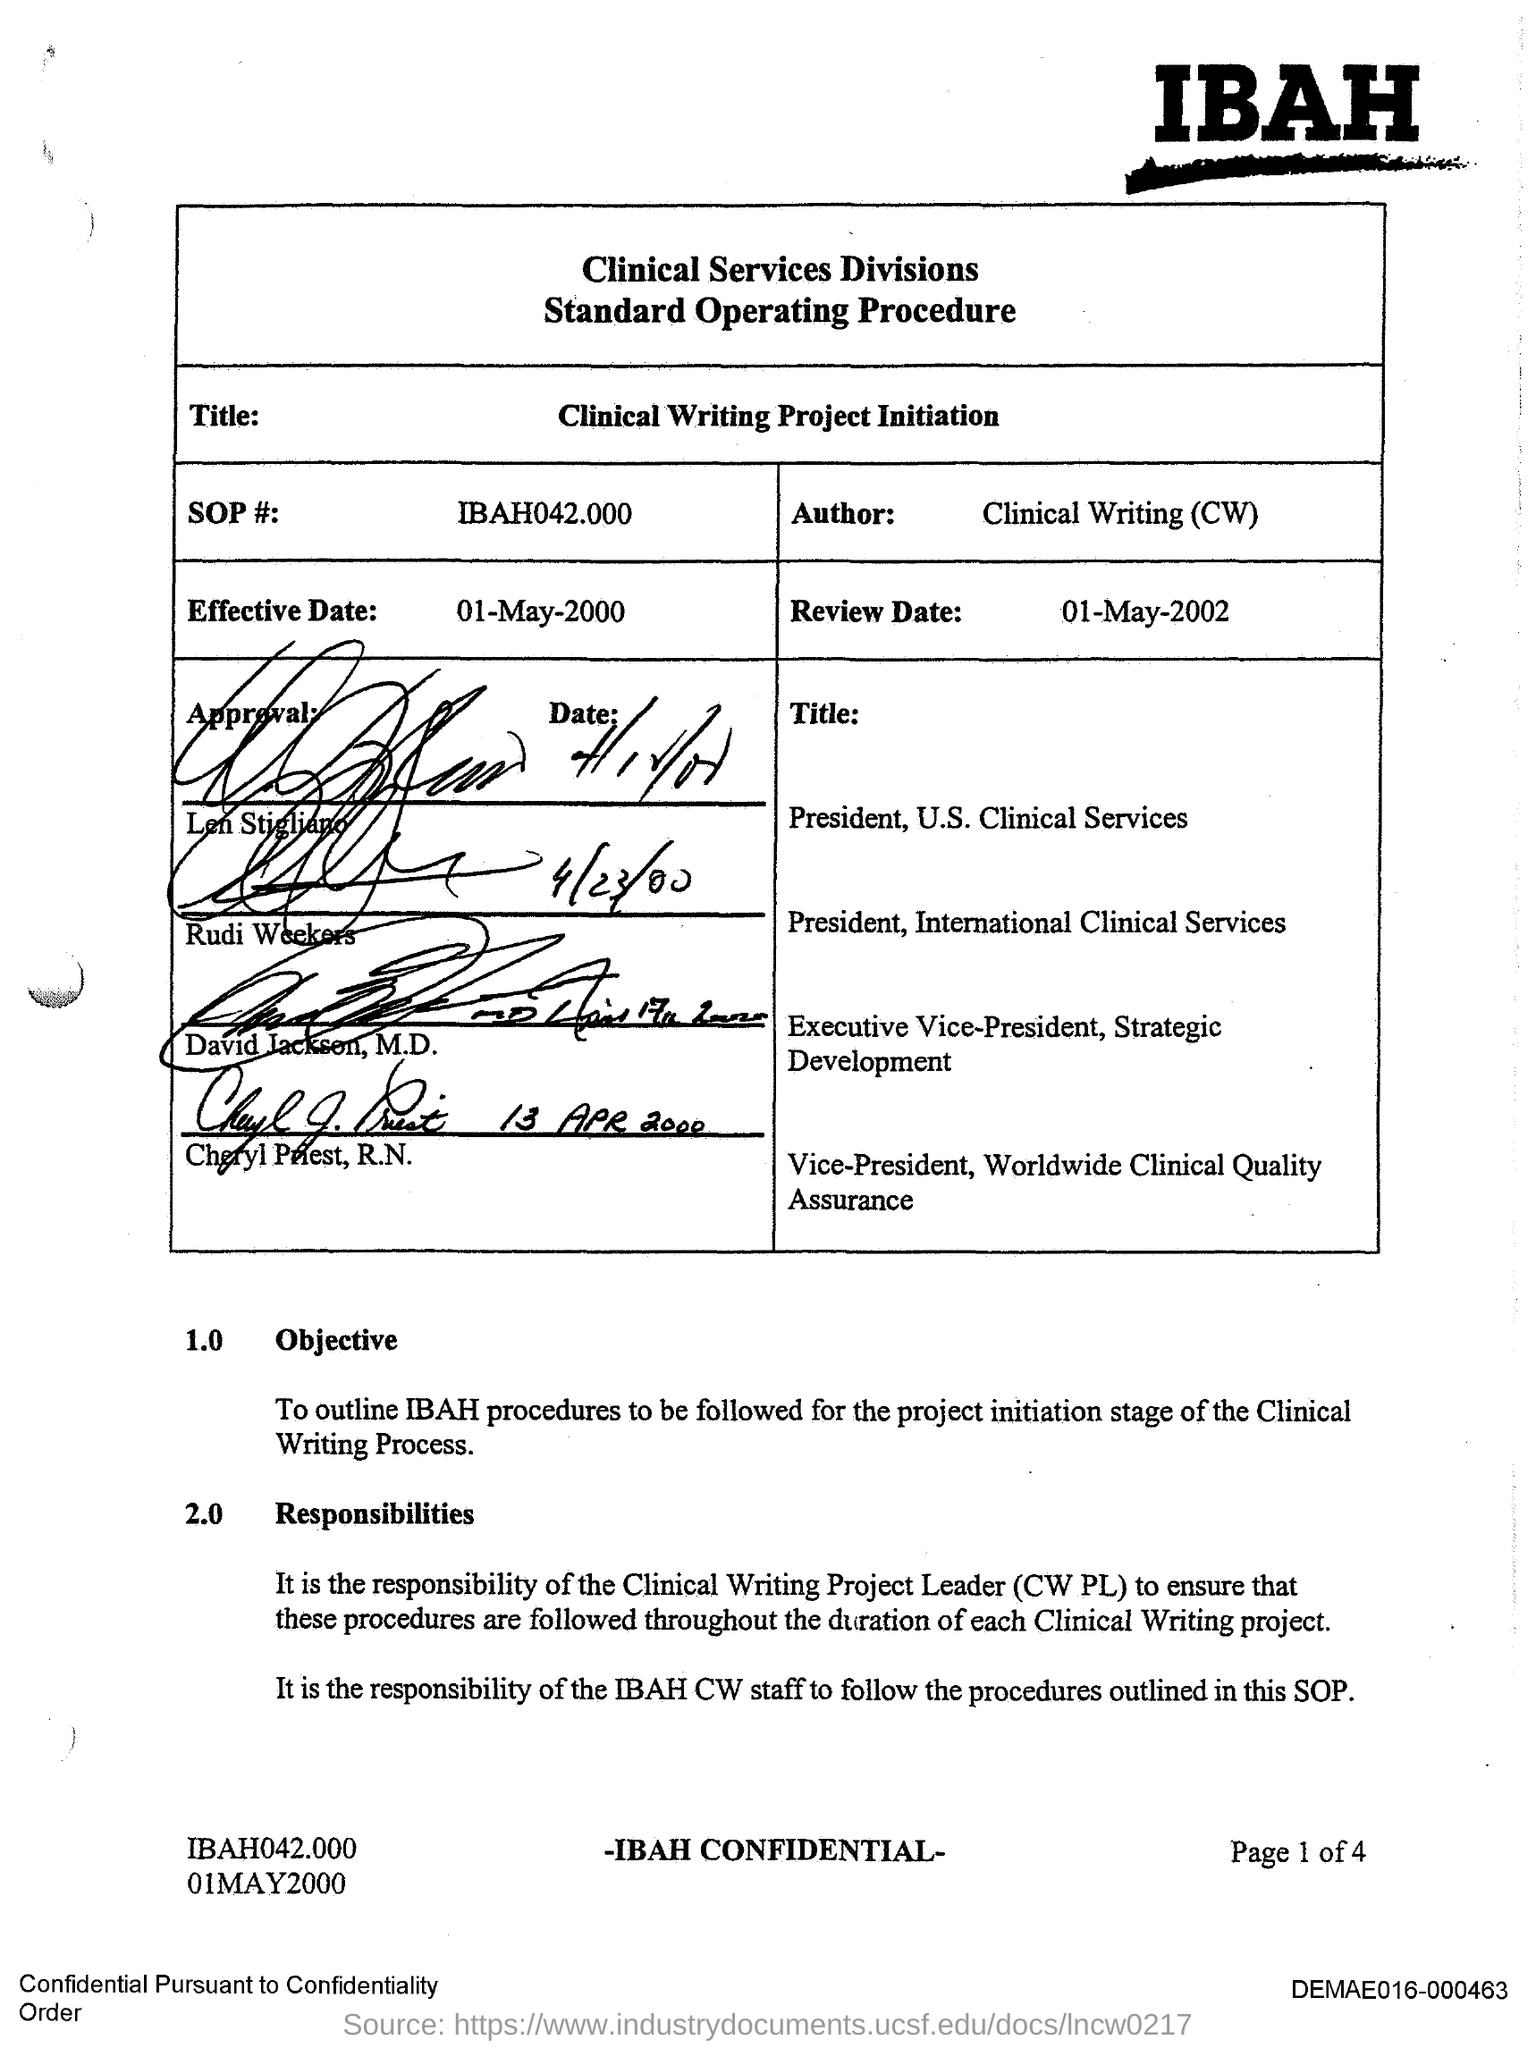List a handful of essential elements in this visual. The author of the clinical writing is... 